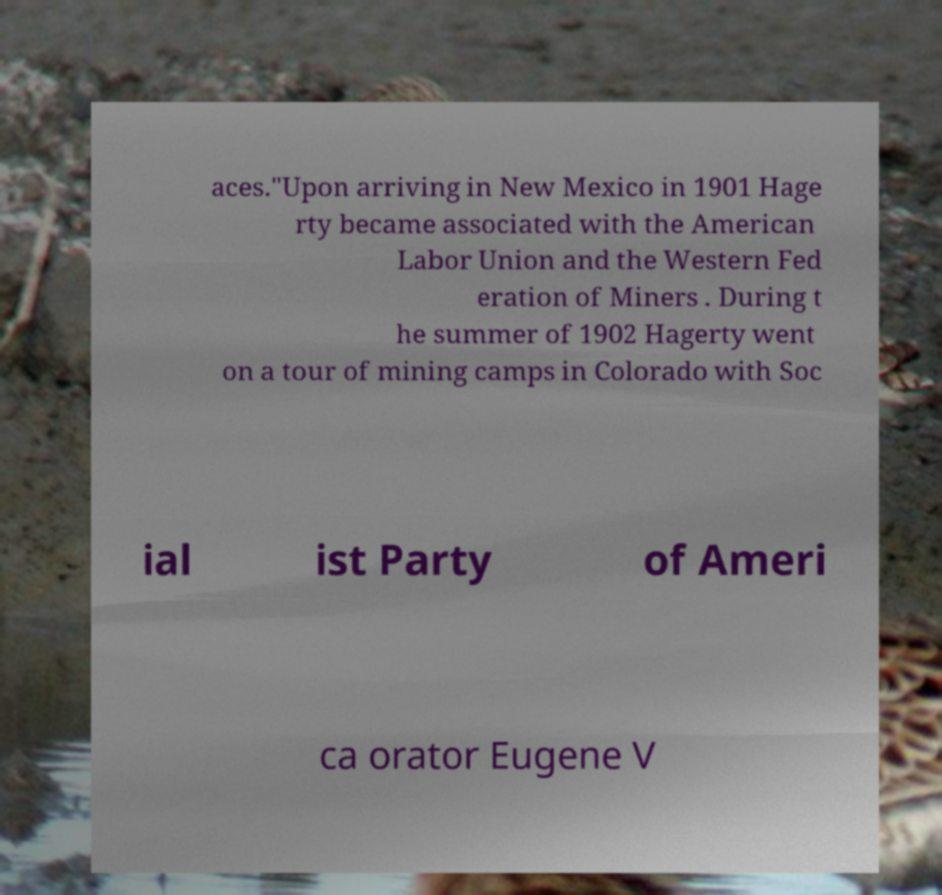Can you accurately transcribe the text from the provided image for me? aces."Upon arriving in New Mexico in 1901 Hage rty became associated with the American Labor Union and the Western Fed eration of Miners . During t he summer of 1902 Hagerty went on a tour of mining camps in Colorado with Soc ial ist Party of Ameri ca orator Eugene V 